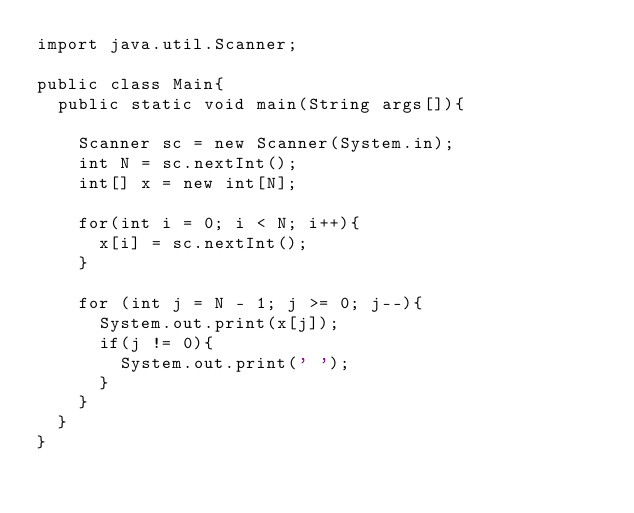Convert code to text. <code><loc_0><loc_0><loc_500><loc_500><_Java_>import java.util.Scanner;

public class Main{
	public static void main(String args[]){

		Scanner sc = new Scanner(System.in);
		int N = sc.nextInt();
		int[] x = new int[N];

		for(int i = 0; i < N; i++){
			x[i] = sc.nextInt();
		}

		for (int j = N - 1; j >= 0; j--){
			System.out.print(x[j]);
			if(j != 0){
				System.out.print(' ');
			}
		}
	}
}</code> 